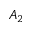Convert formula to latex. <formula><loc_0><loc_0><loc_500><loc_500>A _ { 2 }</formula> 